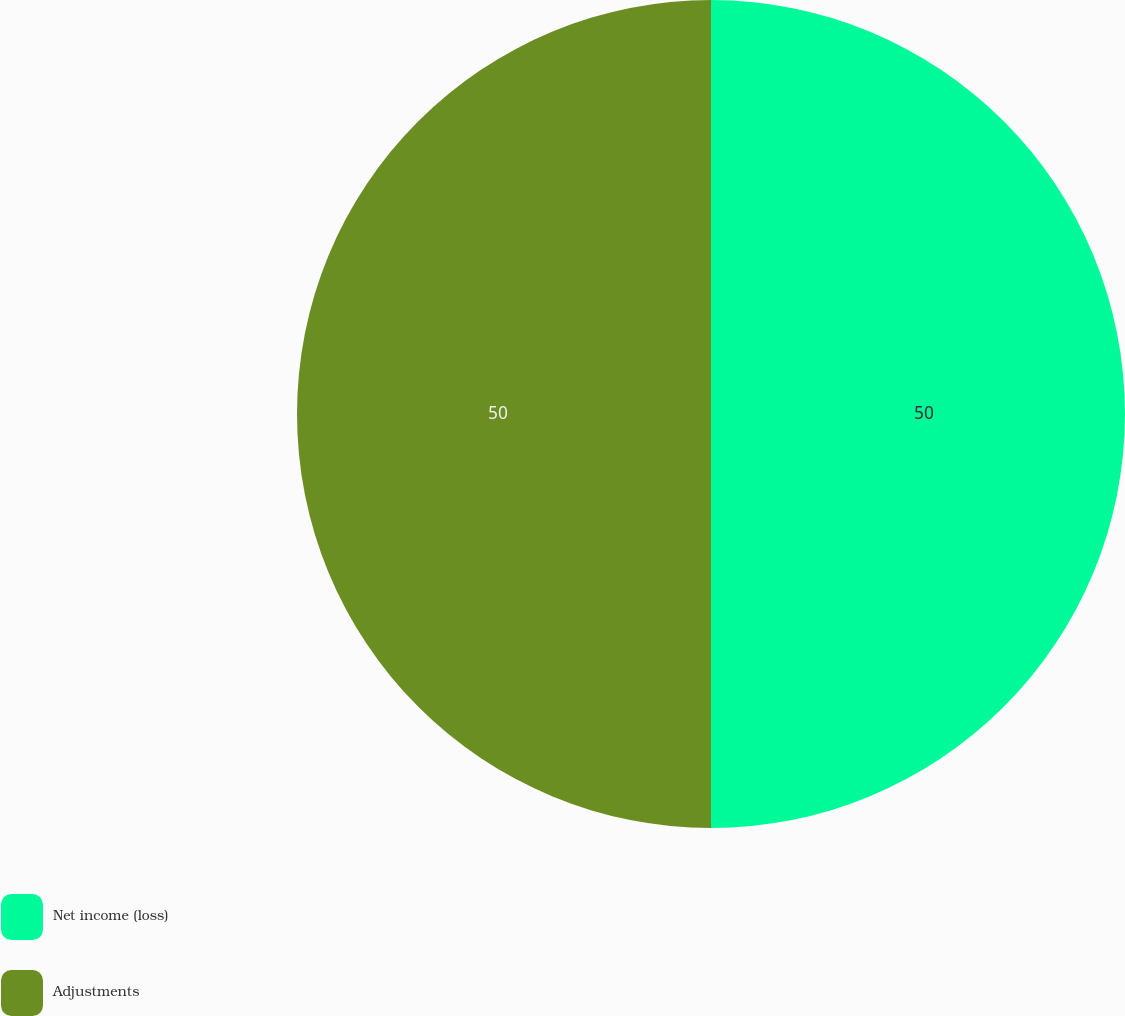<chart> <loc_0><loc_0><loc_500><loc_500><pie_chart><fcel>Net income (loss)<fcel>Adjustments<nl><fcel>50.0%<fcel>50.0%<nl></chart> 